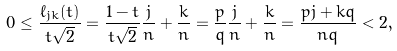<formula> <loc_0><loc_0><loc_500><loc_500>0 \leq \frac { \ell _ { j k } ( t ) } { t \sqrt { 2 } } = \frac { 1 - t } { t \sqrt { 2 } } \frac { j } { n } + \frac { k } { n } = \frac { p } { q } \frac { j } { n } + \frac { k } { n } = \frac { p j + k q } { n q } < 2 ,</formula> 